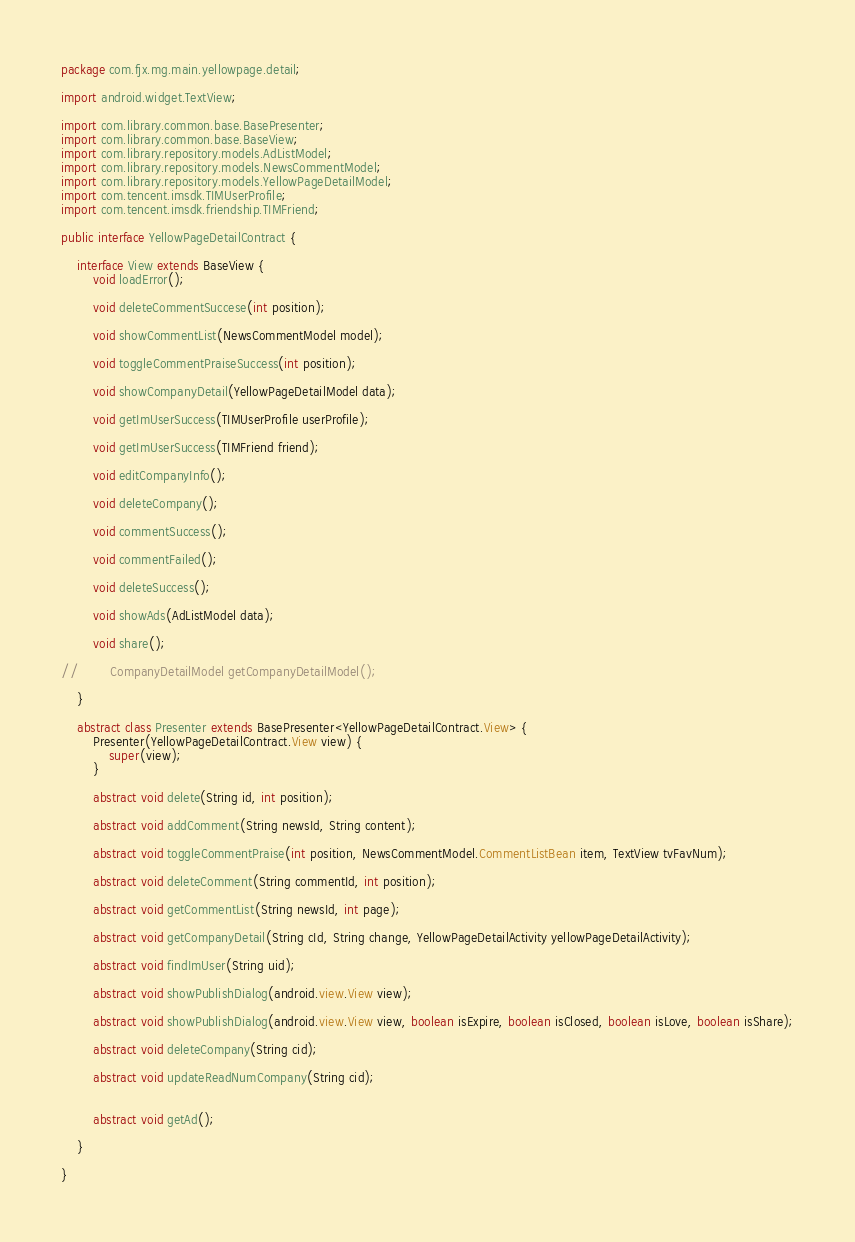Convert code to text. <code><loc_0><loc_0><loc_500><loc_500><_Java_>package com.fjx.mg.main.yellowpage.detail;

import android.widget.TextView;

import com.library.common.base.BasePresenter;
import com.library.common.base.BaseView;
import com.library.repository.models.AdListModel;
import com.library.repository.models.NewsCommentModel;
import com.library.repository.models.YellowPageDetailModel;
import com.tencent.imsdk.TIMUserProfile;
import com.tencent.imsdk.friendship.TIMFriend;

public interface YellowPageDetailContract {

    interface View extends BaseView {
        void loadError();

        void deleteCommentSuccese(int position);

        void showCommentList(NewsCommentModel model);

        void toggleCommentPraiseSuccess(int position);

        void showCompanyDetail(YellowPageDetailModel data);

        void getImUserSuccess(TIMUserProfile userProfile);

        void getImUserSuccess(TIMFriend friend);

        void editCompanyInfo();

        void deleteCompany();

        void commentSuccess();

        void commentFailed();

        void deleteSuccess();

        void showAds(AdListModel data);

        void share();

//        CompanyDetailModel getCompanyDetailModel();

    }

    abstract class Presenter extends BasePresenter<YellowPageDetailContract.View> {
        Presenter(YellowPageDetailContract.View view) {
            super(view);
        }

        abstract void delete(String id, int position);

        abstract void addComment(String newsId, String content);

        abstract void toggleCommentPraise(int position, NewsCommentModel.CommentListBean item, TextView tvFavNum);

        abstract void deleteComment(String commentId, int position);

        abstract void getCommentList(String newsId, int page);

        abstract void getCompanyDetail(String cId, String change, YellowPageDetailActivity yellowPageDetailActivity);

        abstract void findImUser(String uid);

        abstract void showPublishDialog(android.view.View view);

        abstract void showPublishDialog(android.view.View view, boolean isExpire, boolean isClosed, boolean isLove, boolean isShare);

        abstract void deleteCompany(String cid);

        abstract void updateReadNumCompany(String cid);


        abstract void getAd();

    }

}
</code> 